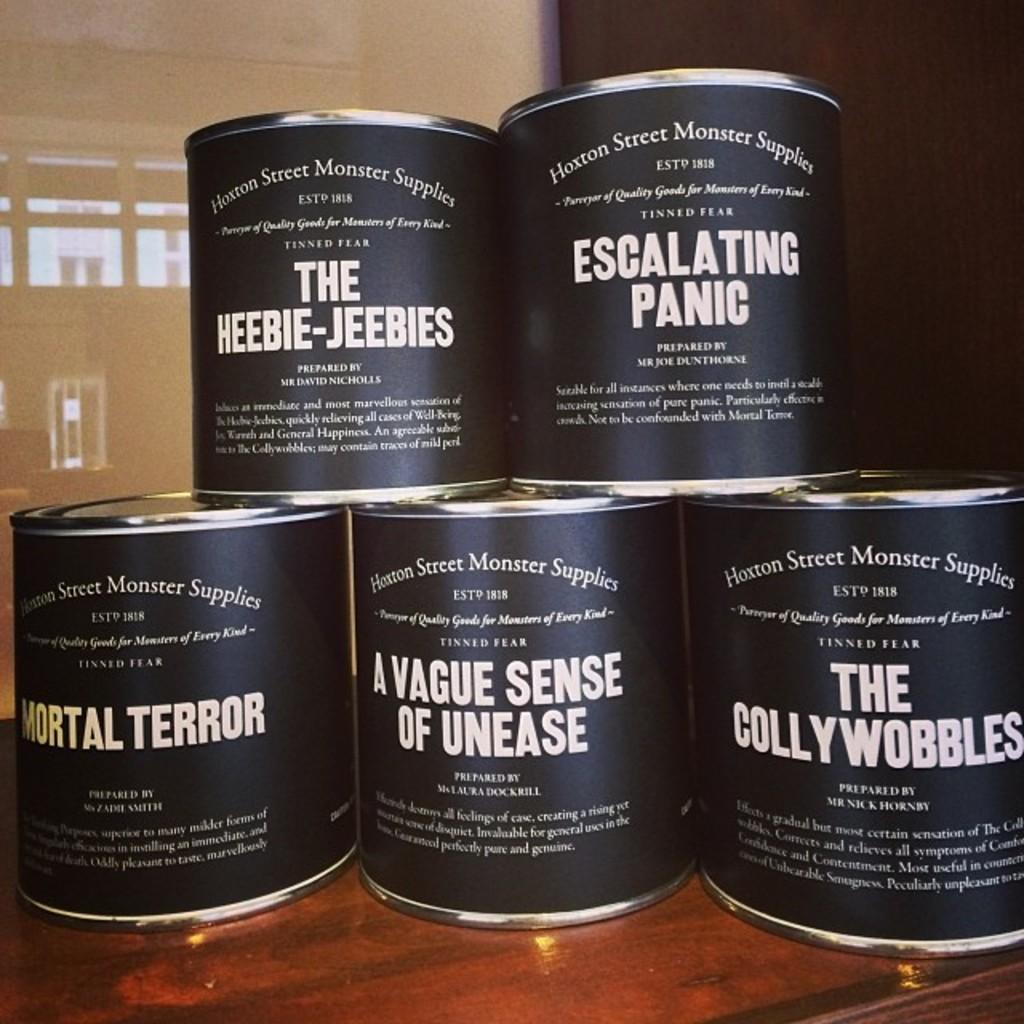<image>
Create a compact narrative representing the image presented. Five cans with humorous labels like Mortal Terror and Escalating Panic are stacked on a table. 